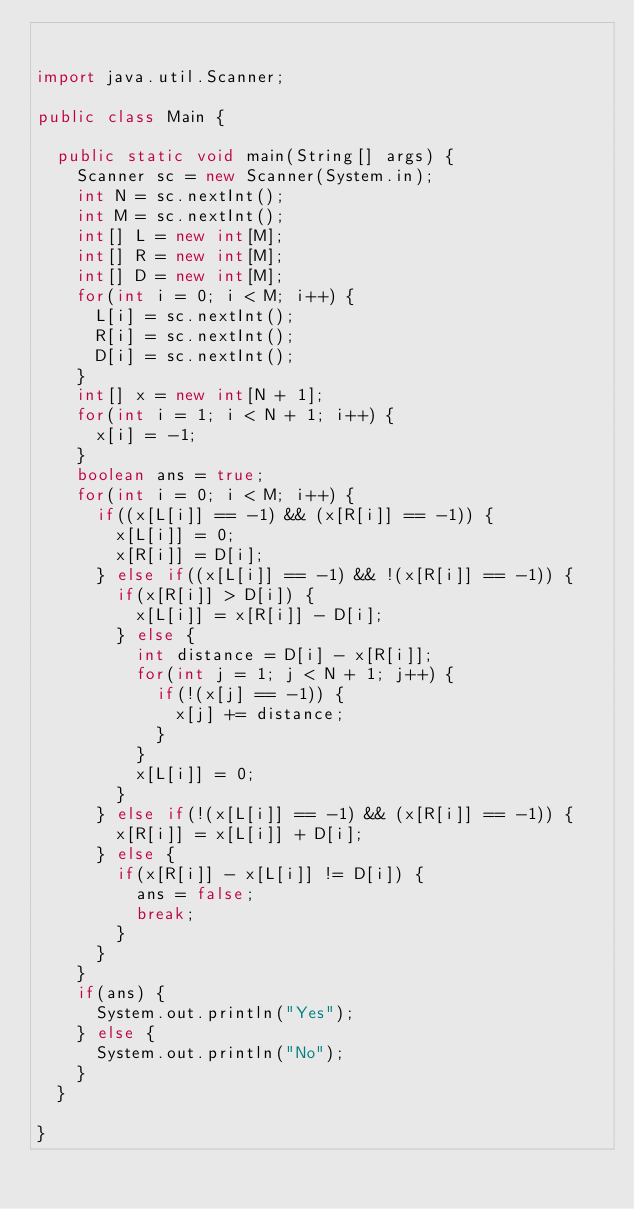<code> <loc_0><loc_0><loc_500><loc_500><_Java_>

import java.util.Scanner;

public class Main {

	public static void main(String[] args) {
		Scanner sc = new Scanner(System.in);
		int N = sc.nextInt();
		int M = sc.nextInt();
		int[] L = new int[M];
		int[] R = new int[M];
		int[] D = new int[M];
		for(int i = 0; i < M; i++) {
			L[i] = sc.nextInt();
			R[i] = sc.nextInt();
			D[i] = sc.nextInt();
		}
		int[] x = new int[N + 1];
		for(int i = 1; i < N + 1; i++) {
			x[i] = -1;
		}
		boolean ans = true;
		for(int i = 0; i < M; i++) {
			if((x[L[i]] == -1) && (x[R[i]] == -1)) {
				x[L[i]] = 0;
				x[R[i]] = D[i];
			} else if((x[L[i]] == -1) && !(x[R[i]] == -1)) {
				if(x[R[i]] > D[i]) {
					x[L[i]] = x[R[i]] - D[i];
				} else {
					int distance = D[i] - x[R[i]];
					for(int j = 1; j < N + 1; j++) {
						if(!(x[j] == -1)) {
							x[j] += distance;
						}
					}
					x[L[i]] = 0;
				}
			} else if(!(x[L[i]] == -1) && (x[R[i]] == -1)) {
				x[R[i]] = x[L[i]] + D[i];
			} else {
				if(x[R[i]] - x[L[i]] != D[i]) {
					ans = false;
					break;
				}
			}
		}
		if(ans) {
			System.out.println("Yes");
		} else {
			System.out.println("No");
		}
	}

}
</code> 